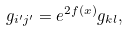Convert formula to latex. <formula><loc_0><loc_0><loc_500><loc_500>g _ { i ^ { \prime } j ^ { \prime } } = e ^ { 2 f ( x ) } g _ { k l } ,</formula> 